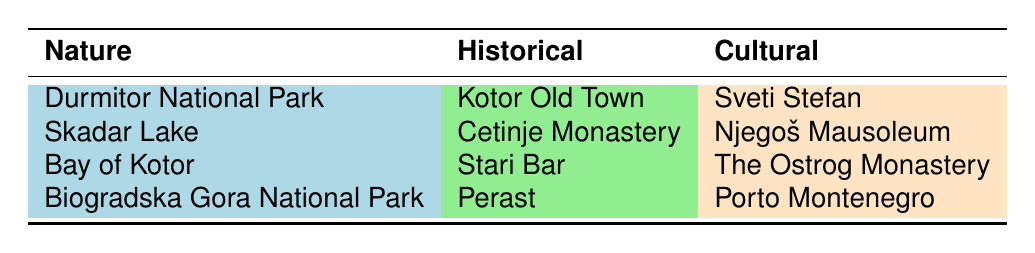What is the only cultural tourist attraction that features a luxury marina? According to the table, Porto Montenegro is the only cultural attraction explicitly mentioned as a luxury marina.
Answer: Porto Montenegro How many historical attractions are listed in the table? The table lists five historical attractions: Kotor Old Town, Cetinje Monastery, Stari Bar, Perast, and the Ostrog Monastery.
Answer: 5 Is the Bay of Kotor classified under nature or cultural attractions? Based on the table, the Bay of Kotor is categorized as a nature attraction.
Answer: Nature What is the total number of nature attractions mentioned in the table? There are four nature attractions: Durmitor National Park, Skadar Lake, Bay of Kotor, and Biogradska Gora National Park.
Answer: 4 Which historical attraction is known for its medieval architecture? Kotor Old Town is recognized for its well-preserved medieval architecture as stated in the table.
Answer: Kotor Old Town Are there any cultural attractions that are not associated with religious significance? Yes, Sveti Stefan is a cultural attraction known for its luxury resort and traditional stone buildings, with no direct religious significance stated in the table.
Answer: Yes Of the listed attractions, which one is the highest in elevation? The Njegoš Mausoleum, located on Mount Lovćen, suggests a higher elevation than other attractions listed in the table.
Answer: Njegoš Mausoleum Which type of attraction has the greatest variety according to the table? The table shows three types—nature, historical, and cultural—with nature attractions being more numerous, totaling four compared to three cultural and five historical.
Answer: Nature What is the significance of the Cetinje Monastery? The table describes the Cetinje Monastery as a significant cultural and historical site with a rich collection of religious relics, indicating its importance.
Answer: Cultural and historical significance 